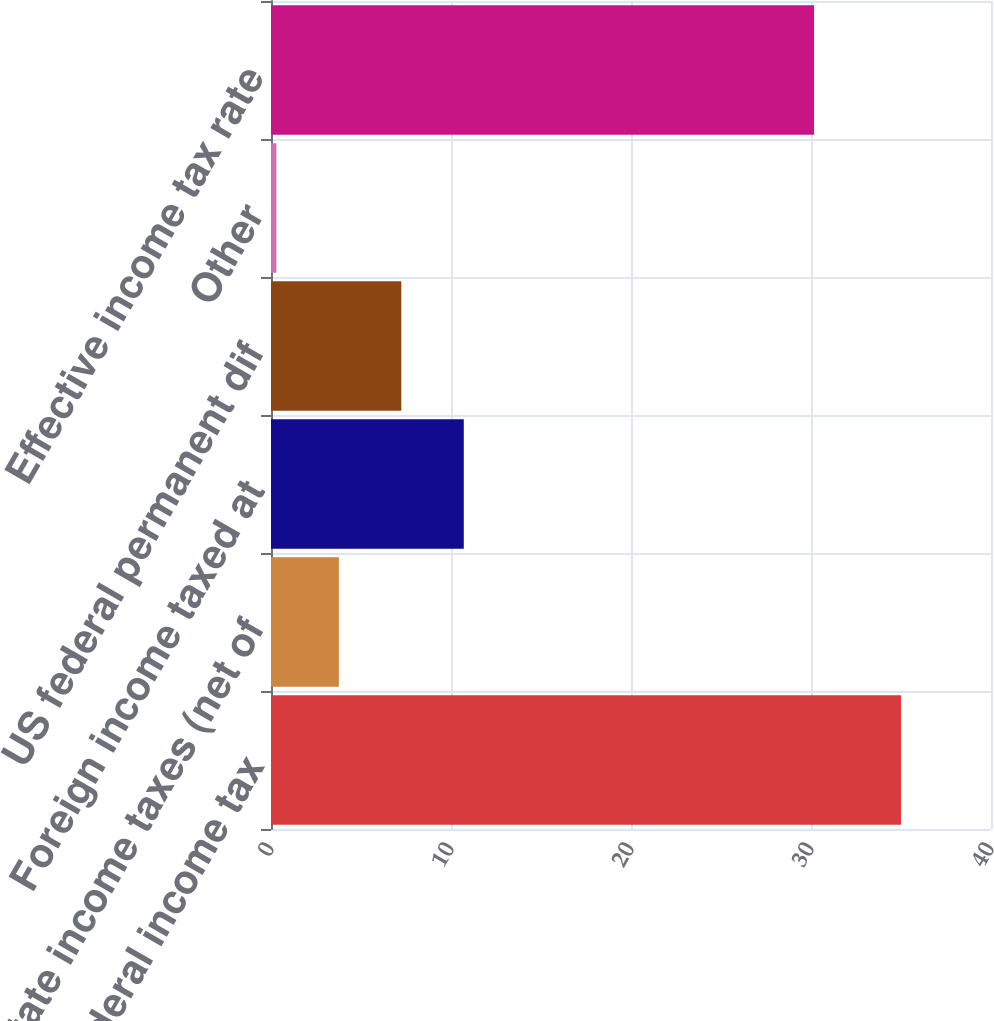Convert chart. <chart><loc_0><loc_0><loc_500><loc_500><bar_chart><fcel>Statutory federal income tax<fcel>State income taxes (net of<fcel>Foreign income taxed at<fcel>US federal permanent dif<fcel>Other<fcel>Effective income tax rate<nl><fcel>35<fcel>3.77<fcel>10.71<fcel>7.24<fcel>0.3<fcel>30.17<nl></chart> 